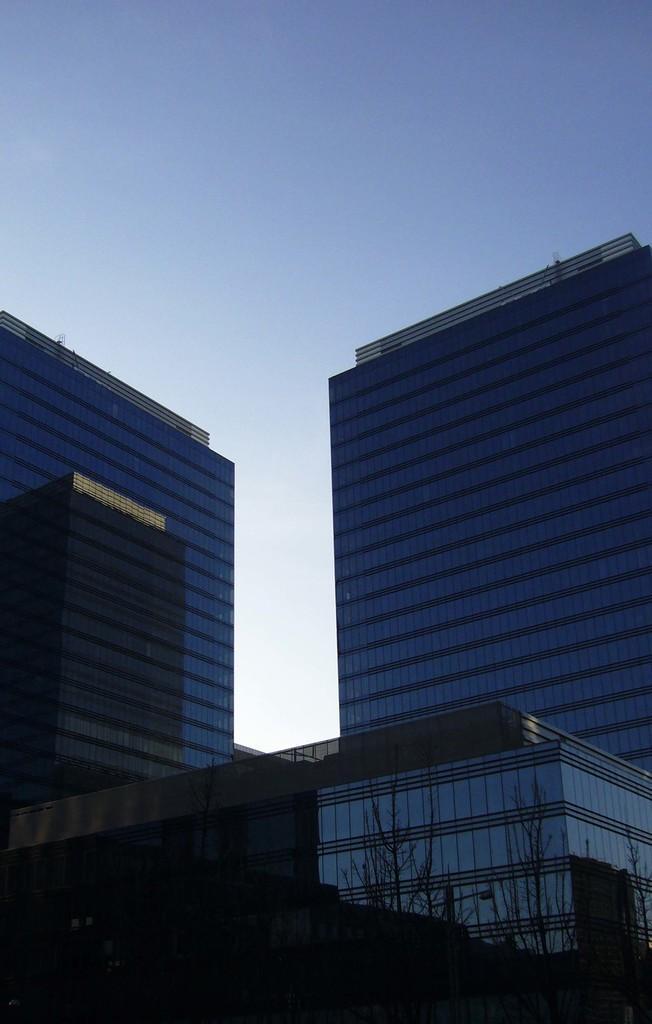Please provide a concise description of this image. In the picture there are two tall buildings they are completely covered with glasses and in between them there is another small building it is also covered with glasses and in the background there is a sky. 